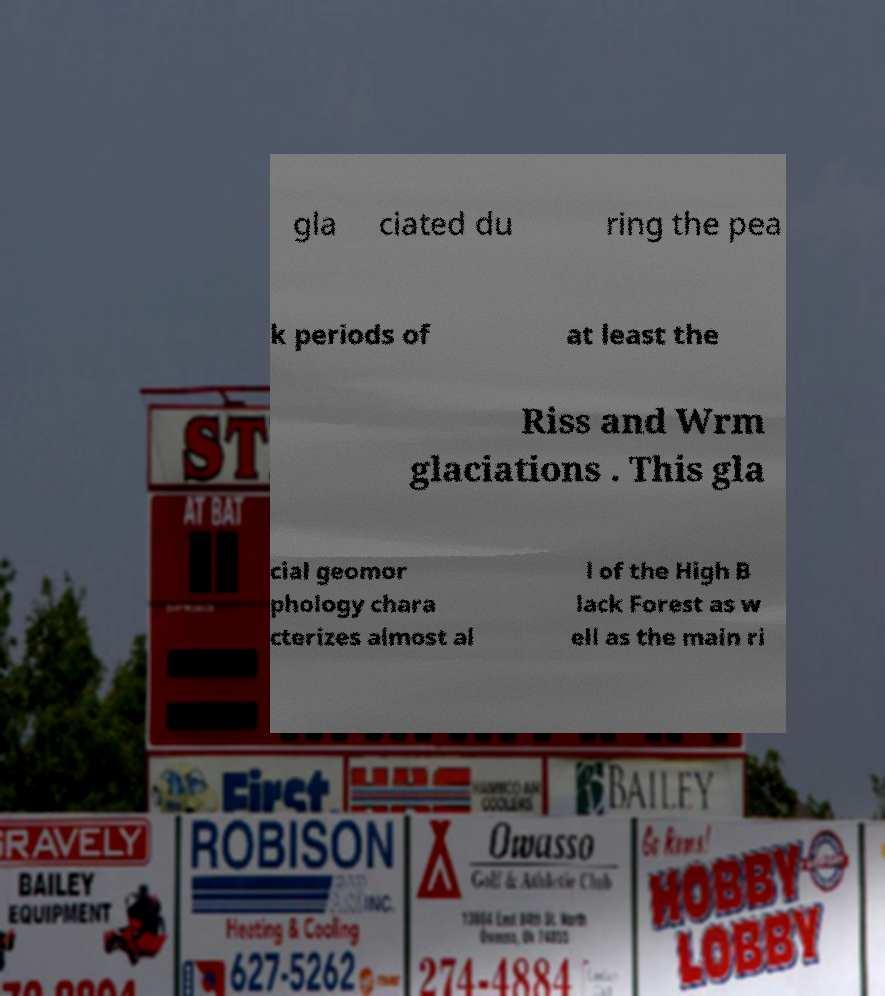There's text embedded in this image that I need extracted. Can you transcribe it verbatim? gla ciated du ring the pea k periods of at least the Riss and Wrm glaciations . This gla cial geomor phology chara cterizes almost al l of the High B lack Forest as w ell as the main ri 